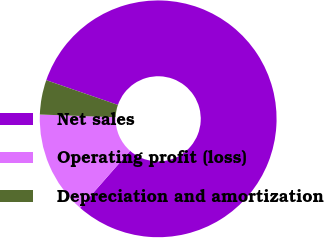<chart> <loc_0><loc_0><loc_500><loc_500><pie_chart><fcel>Net sales<fcel>Operating profit (loss)<fcel>Depreciation and amortization<nl><fcel>81.18%<fcel>14.12%<fcel>4.71%<nl></chart> 